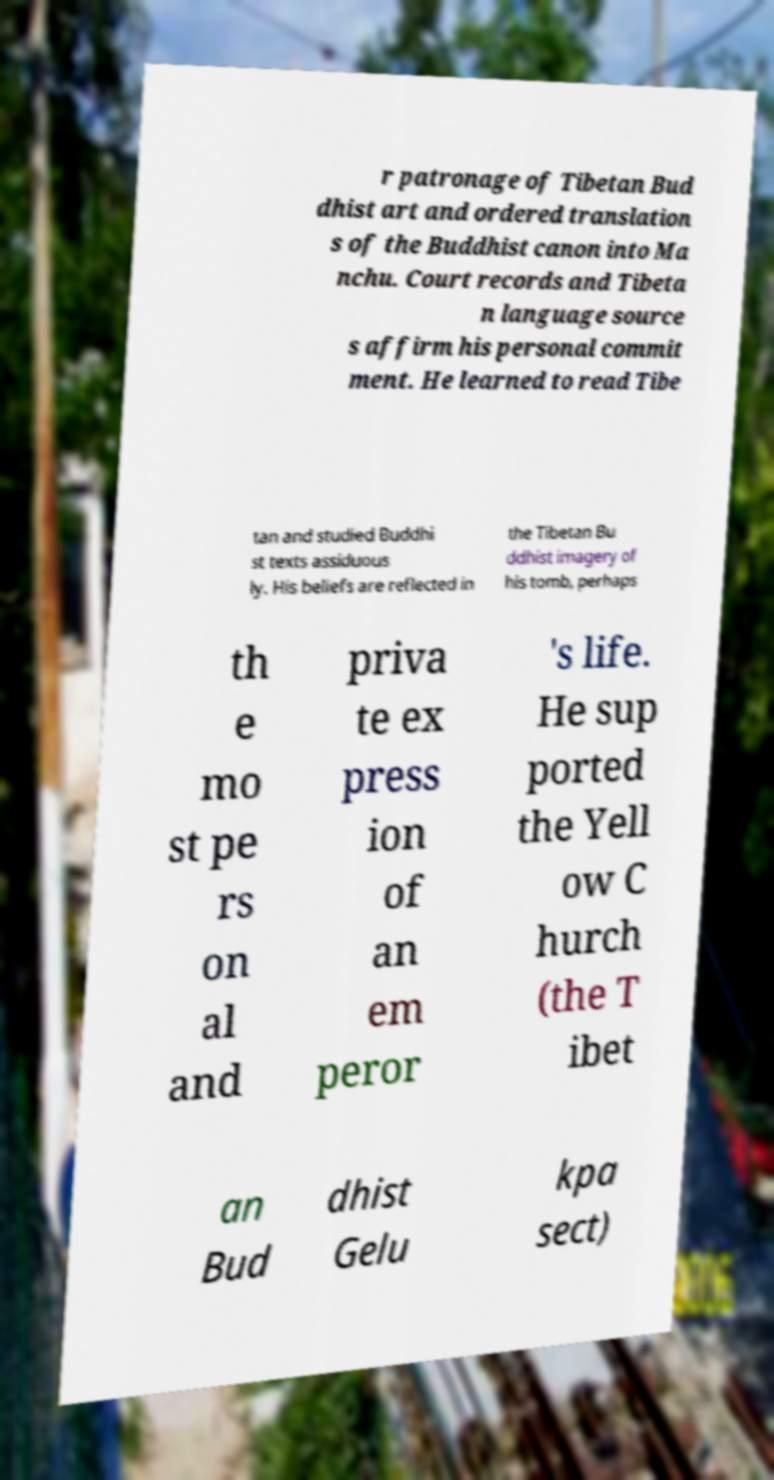Please read and relay the text visible in this image. What does it say? r patronage of Tibetan Bud dhist art and ordered translation s of the Buddhist canon into Ma nchu. Court records and Tibeta n language source s affirm his personal commit ment. He learned to read Tibe tan and studied Buddhi st texts assiduous ly. His beliefs are reflected in the Tibetan Bu ddhist imagery of his tomb, perhaps th e mo st pe rs on al and priva te ex press ion of an em peror 's life. He sup ported the Yell ow C hurch (the T ibet an Bud dhist Gelu kpa sect) 